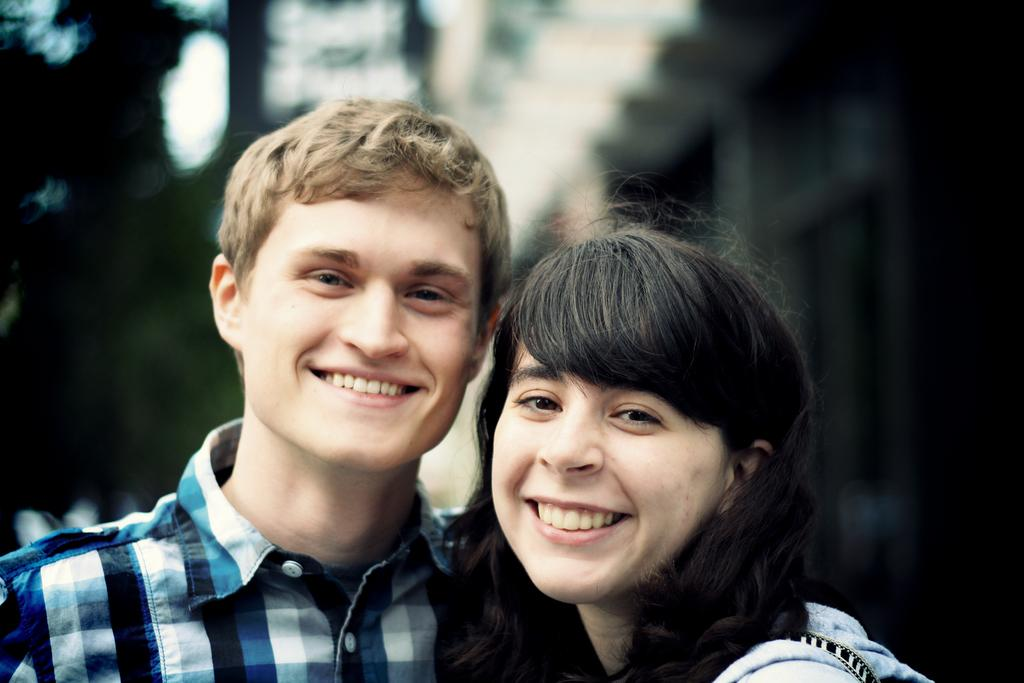Who are the main subjects in the foreground of the picture? There is a man and a woman in the foreground of the picture. What are the expressions on their faces? Both the man and the woman are smiling. Can you describe the background of the image? The background of the image is blurred. What type of cattle can be seen grazing in the background of the image? There are no cattle present in the image; the background is blurred. What items are on the list that the man and woman are holding in the image? There is no list present in the image. What type of snack is being shared by the man and woman in the image? There is no snack, such as popcorn, present in the image. 